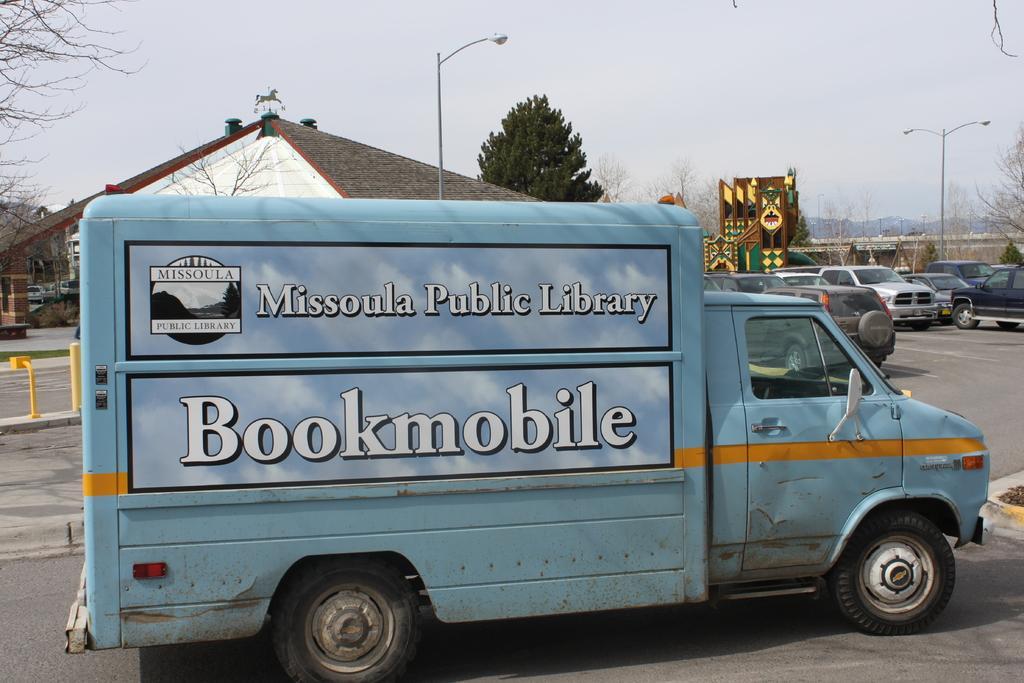How would you summarize this image in a sentence or two? In this picture we can see a few vehicles on the road. There is a house and street lights are visible in the background. 